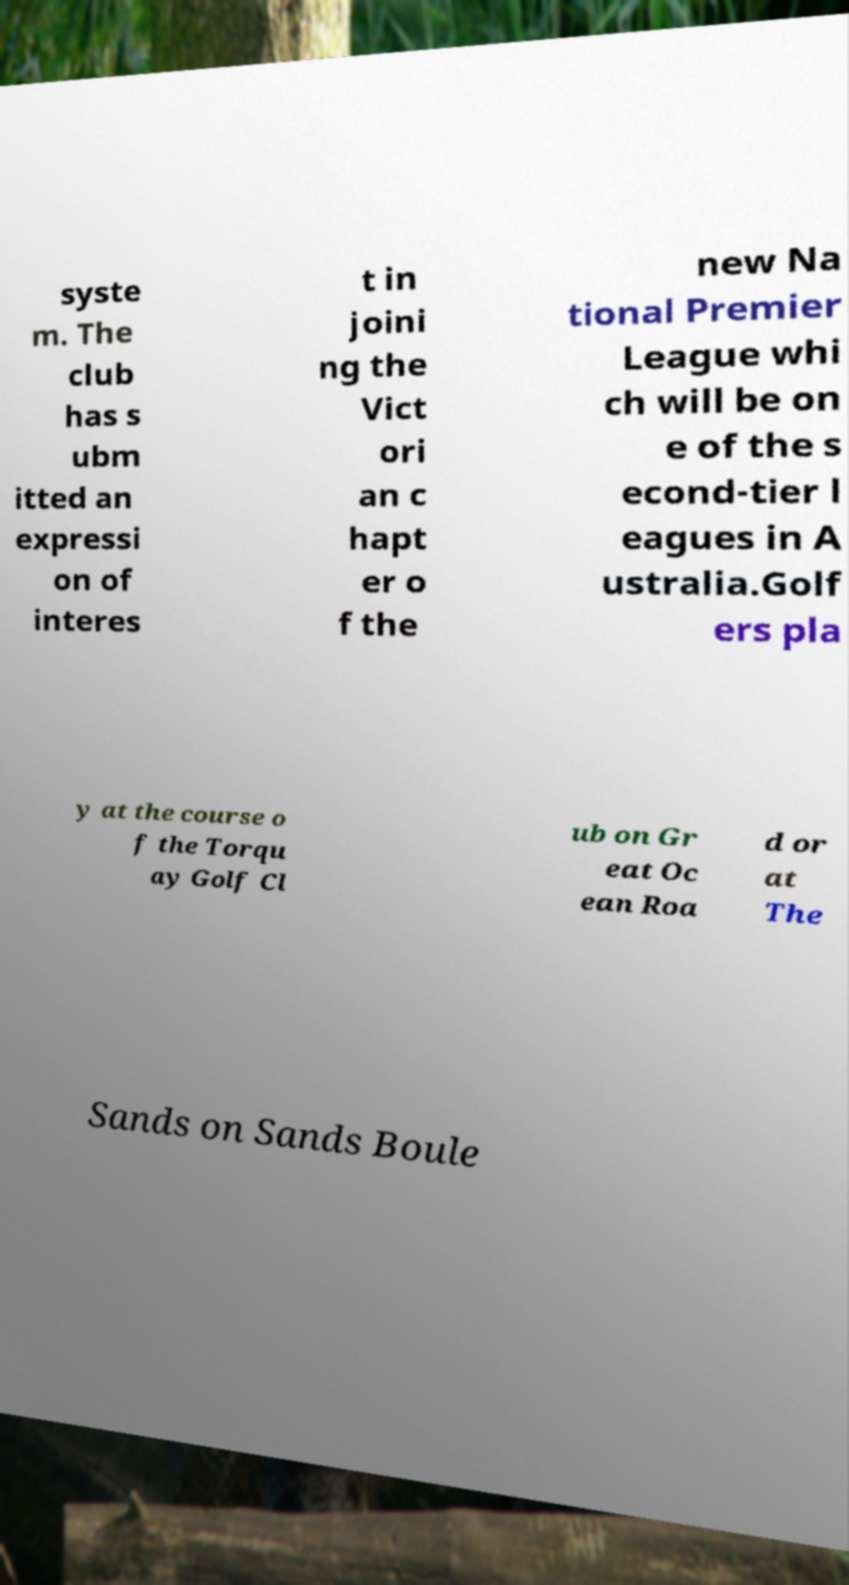What messages or text are displayed in this image? I need them in a readable, typed format. syste m. The club has s ubm itted an expressi on of interes t in joini ng the Vict ori an c hapt er o f the new Na tional Premier League whi ch will be on e of the s econd-tier l eagues in A ustralia.Golf ers pla y at the course o f the Torqu ay Golf Cl ub on Gr eat Oc ean Roa d or at The Sands on Sands Boule 